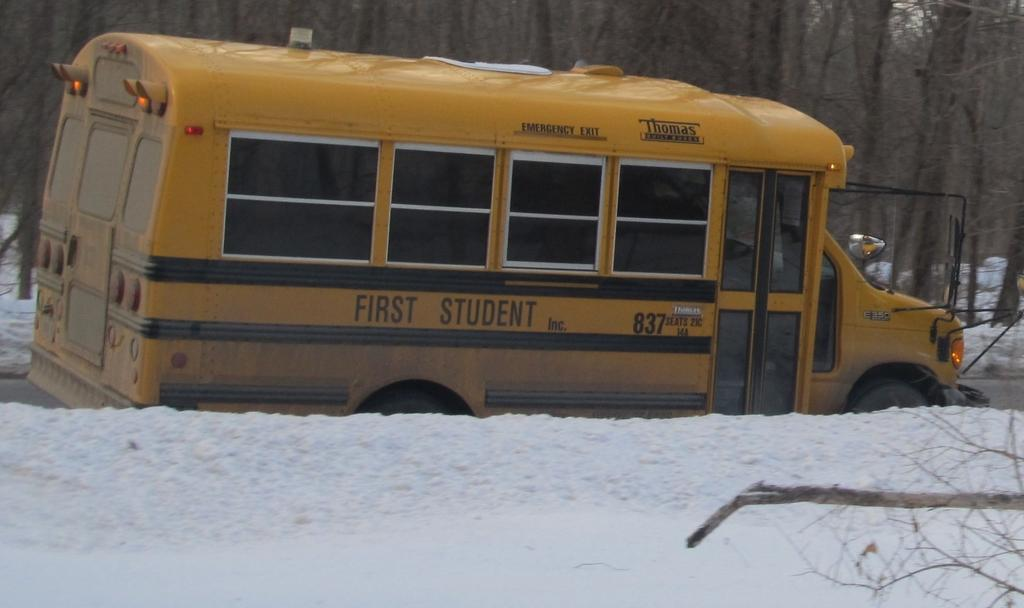Provide a one-sentence caption for the provided image. A "First Student" school bus parked next to a snow bank. 